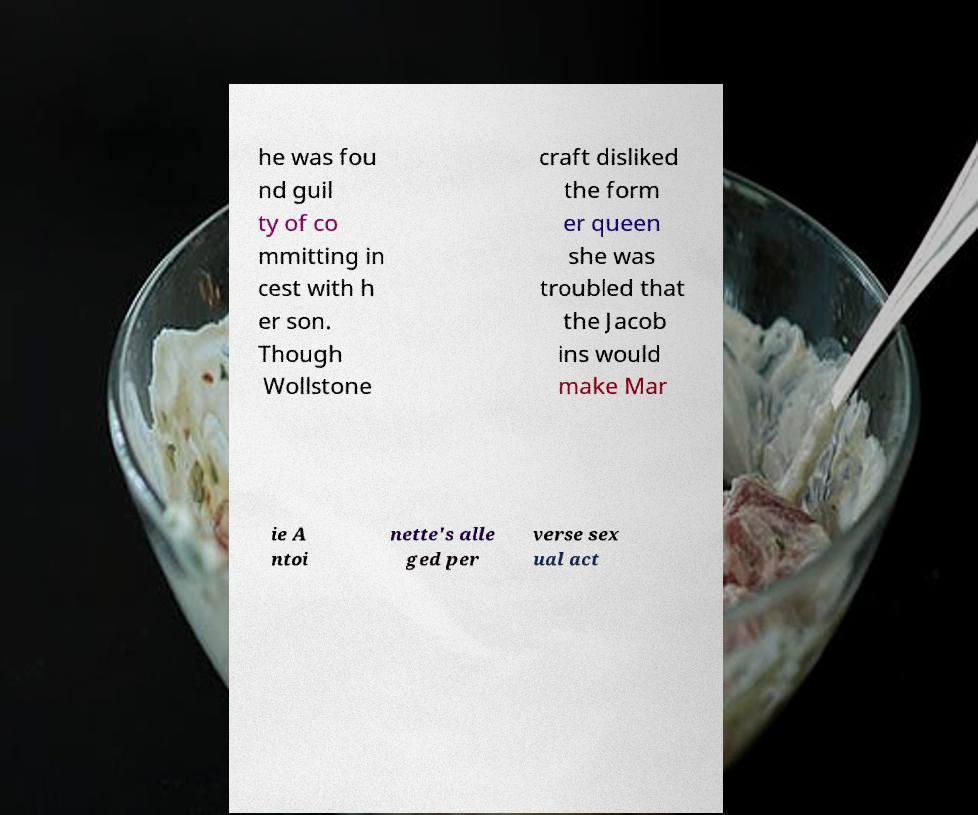I need the written content from this picture converted into text. Can you do that? he was fou nd guil ty of co mmitting in cest with h er son. Though Wollstone craft disliked the form er queen she was troubled that the Jacob ins would make Mar ie A ntoi nette's alle ged per verse sex ual act 